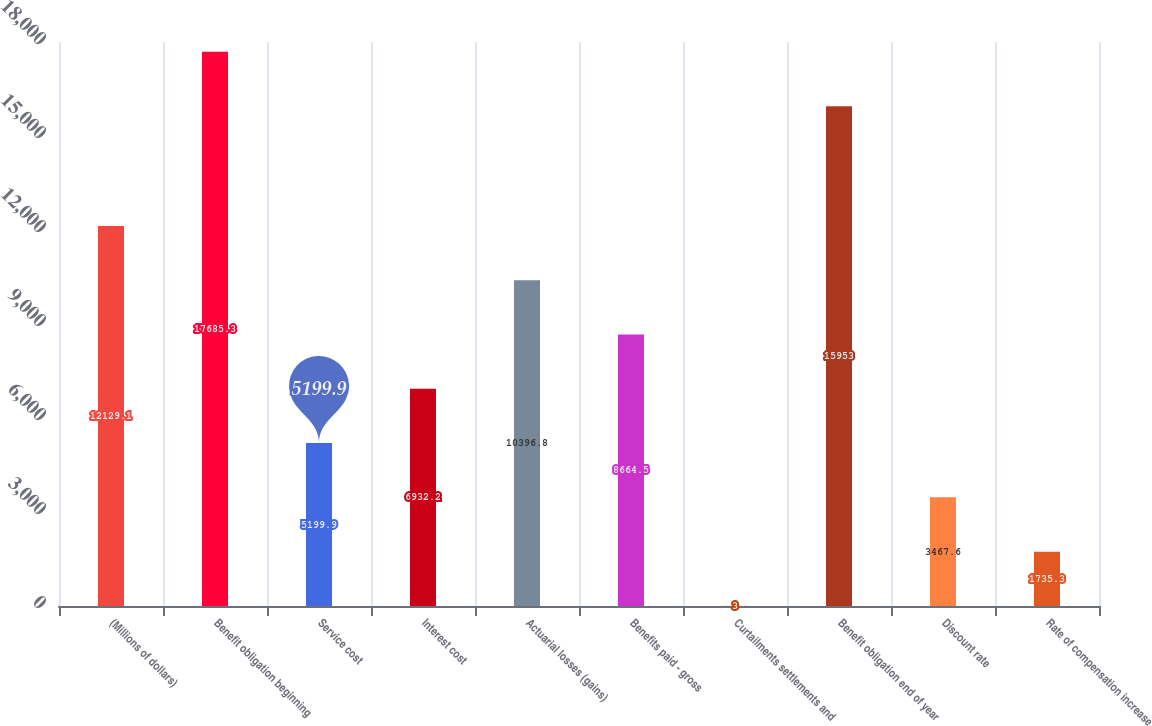<chart> <loc_0><loc_0><loc_500><loc_500><bar_chart><fcel>(Millions of dollars)<fcel>Benefit obligation beginning<fcel>Service cost<fcel>Interest cost<fcel>Actuarial losses (gains)<fcel>Benefits paid - gross<fcel>Curtailments settlements and<fcel>Benefit obligation end of year<fcel>Discount rate<fcel>Rate of compensation increase<nl><fcel>12129.1<fcel>17685.3<fcel>5199.9<fcel>6932.2<fcel>10396.8<fcel>8664.5<fcel>3<fcel>15953<fcel>3467.6<fcel>1735.3<nl></chart> 